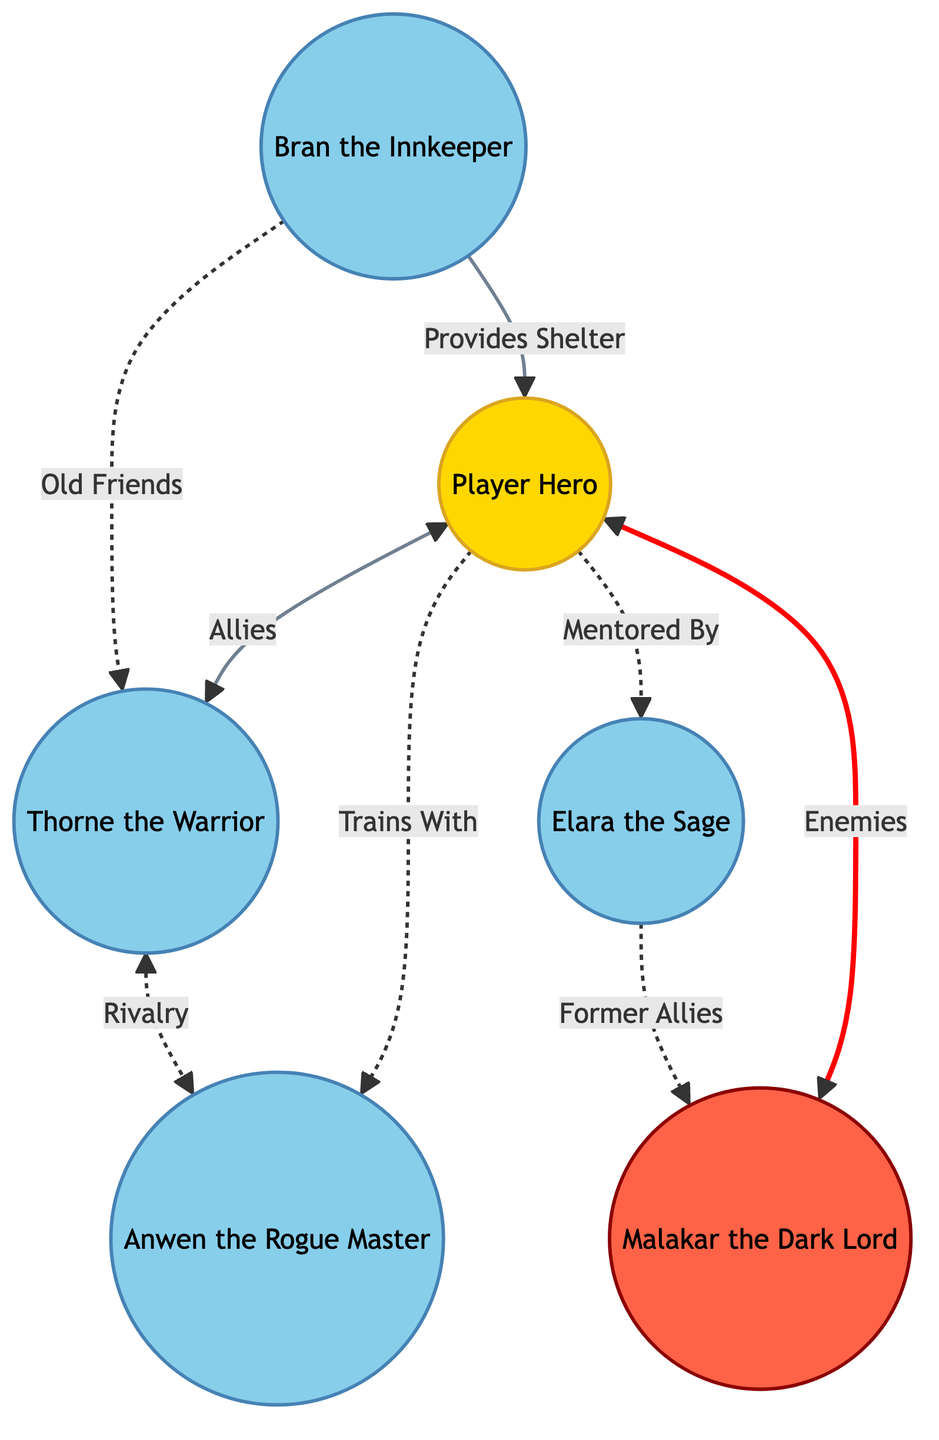What is the relationship between the Player Hero and Elara the Sage? The diagram indicates that the Player Hero is "Mentored By" Elara the Sage. This can be identified by following the edge labeled "Mentored By" from the Player Hero node to the Elara the Sage node.
Answer: Mentored By How many NPCs are in the diagram? The diagram includes a total of five NPCs: Elara the Sage, Thorne the Warrior, Anwen the Rogue Master, Malakar the Dark Lord, and Bran the Innkeeper. Counting these nodes gives us the total.
Answer: 5 What kind of relationship does Thorne the Warrior have with Malakar the Dark Lord? The diagram does not depict a direct connection between Thorne the Warrior and Malakar the Dark Lord, but they are implied to have no direct relationship. We can infer this since the only connections involving Thorne are with the Player Hero and Anwen the Rogue Master.
Answer: None How are Anwen the Rogue Master and Thorne the Warrior connected? The connection between Anwen the Rogue Master and Thorne the Warrior is a "Rivalry," as indicated by the edge labeled "Rivalry" in the diagram. This relationship can be observed by examining the edge connecting these two nodes.
Answer: Rivalry Who provides shelter to the Player Hero? The diagram shows that Bran the Innkeeper provides shelter to the Player Hero. This is confirmed by following the arrow labeled "Provides Shelter" from Bran to the Player Hero node in the diagram.
Answer: Bran the Innkeeper Which character is an enemy of the Player Hero? The Player Hero has a relationship labeled "Enemies" with Malakar the Dark Lord. This is seen in the edge labeled "Enemies," directly connecting these two nodes in the diagram.
Answer: Malakar the Dark Lord What is the nature of the relationship between Malakar the Dark Lord and Elara the Sage? Malakar the Dark Lord is identified as a "Former Allies" with Elara the Sage, according to the edge that connects them. This indicates a past connection that has since changed.
Answer: Former Allies What role does Bran the Innkeeper play in relation to Thorne the Warrior? Bran the Innkeeper and Thorne the Warrior are described as "Old Friends," according to the relationship edge connecting these two characters in the diagram.
Answer: Old Friends How does the Player Hero relate to the NPCs overall? The Player Hero interacts with all four NPCs (Elara the Sage, Thorne the Warrior, Anwen the Rogue Master, and Malakar the Dark Lord) through different types of relationships: mentoring, alliance, training, and enmity. This indicates a complex dynamic and involvement with multiple characters.
Answer: Multiple Relationships 